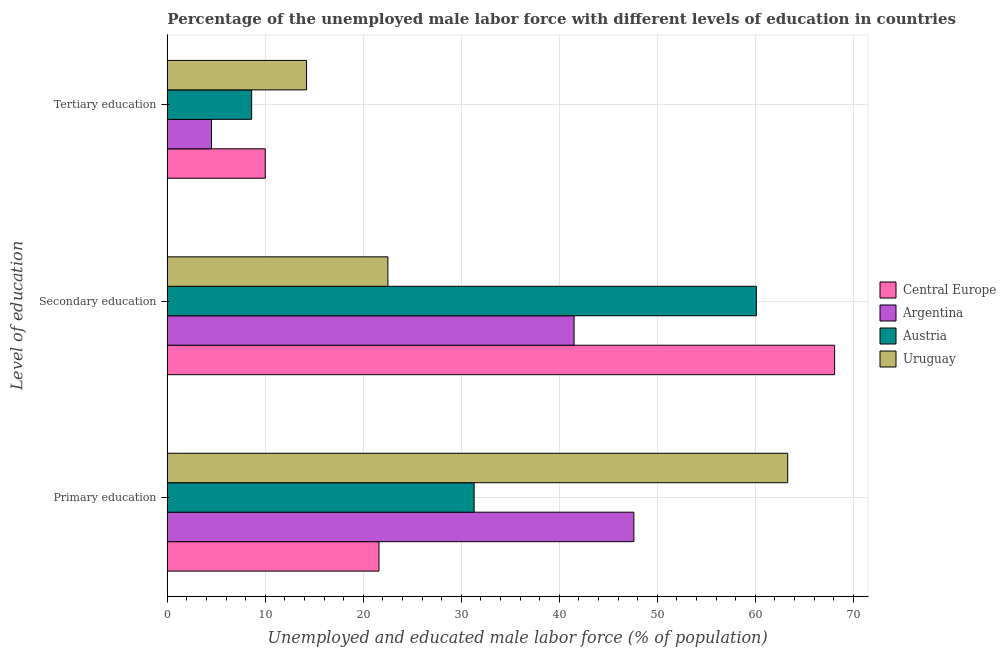How many groups of bars are there?
Your answer should be compact. 3. Are the number of bars on each tick of the Y-axis equal?
Your response must be concise. Yes. How many bars are there on the 1st tick from the top?
Give a very brief answer. 4. Across all countries, what is the maximum percentage of male labor force who received secondary education?
Your response must be concise. 68.09. In which country was the percentage of male labor force who received primary education maximum?
Offer a very short reply. Uruguay. In which country was the percentage of male labor force who received secondary education minimum?
Give a very brief answer. Uruguay. What is the total percentage of male labor force who received tertiary education in the graph?
Provide a short and direct response. 37.28. What is the difference between the percentage of male labor force who received secondary education in Austria and that in Central Europe?
Your response must be concise. -7.99. What is the difference between the percentage of male labor force who received primary education in Uruguay and the percentage of male labor force who received secondary education in Central Europe?
Give a very brief answer. -4.79. What is the average percentage of male labor force who received secondary education per country?
Offer a terse response. 48.05. What is the difference between the percentage of male labor force who received tertiary education and percentage of male labor force who received primary education in Uruguay?
Offer a terse response. -49.1. What is the ratio of the percentage of male labor force who received primary education in Argentina to that in Austria?
Ensure brevity in your answer.  1.52. Is the percentage of male labor force who received secondary education in Uruguay less than that in Argentina?
Your answer should be very brief. Yes. What is the difference between the highest and the second highest percentage of male labor force who received tertiary education?
Your answer should be very brief. 4.22. What is the difference between the highest and the lowest percentage of male labor force who received tertiary education?
Your answer should be compact. 9.7. In how many countries, is the percentage of male labor force who received secondary education greater than the average percentage of male labor force who received secondary education taken over all countries?
Provide a short and direct response. 2. What does the 2nd bar from the top in Primary education represents?
Your answer should be compact. Austria. What does the 3rd bar from the bottom in Secondary education represents?
Give a very brief answer. Austria. How many bars are there?
Offer a very short reply. 12. What is the difference between two consecutive major ticks on the X-axis?
Your answer should be very brief. 10. Are the values on the major ticks of X-axis written in scientific E-notation?
Your answer should be very brief. No. Does the graph contain any zero values?
Give a very brief answer. No. Where does the legend appear in the graph?
Offer a terse response. Center right. How are the legend labels stacked?
Your answer should be very brief. Vertical. What is the title of the graph?
Provide a short and direct response. Percentage of the unemployed male labor force with different levels of education in countries. What is the label or title of the X-axis?
Your answer should be very brief. Unemployed and educated male labor force (% of population). What is the label or title of the Y-axis?
Ensure brevity in your answer.  Level of education. What is the Unemployed and educated male labor force (% of population) in Central Europe in Primary education?
Keep it short and to the point. 21.59. What is the Unemployed and educated male labor force (% of population) of Argentina in Primary education?
Offer a terse response. 47.6. What is the Unemployed and educated male labor force (% of population) of Austria in Primary education?
Ensure brevity in your answer.  31.3. What is the Unemployed and educated male labor force (% of population) of Uruguay in Primary education?
Offer a very short reply. 63.3. What is the Unemployed and educated male labor force (% of population) in Central Europe in Secondary education?
Your response must be concise. 68.09. What is the Unemployed and educated male labor force (% of population) of Argentina in Secondary education?
Offer a terse response. 41.5. What is the Unemployed and educated male labor force (% of population) in Austria in Secondary education?
Keep it short and to the point. 60.1. What is the Unemployed and educated male labor force (% of population) in Central Europe in Tertiary education?
Provide a short and direct response. 9.98. What is the Unemployed and educated male labor force (% of population) in Austria in Tertiary education?
Provide a short and direct response. 8.6. What is the Unemployed and educated male labor force (% of population) in Uruguay in Tertiary education?
Provide a short and direct response. 14.2. Across all Level of education, what is the maximum Unemployed and educated male labor force (% of population) of Central Europe?
Offer a terse response. 68.09. Across all Level of education, what is the maximum Unemployed and educated male labor force (% of population) of Argentina?
Ensure brevity in your answer.  47.6. Across all Level of education, what is the maximum Unemployed and educated male labor force (% of population) in Austria?
Offer a terse response. 60.1. Across all Level of education, what is the maximum Unemployed and educated male labor force (% of population) in Uruguay?
Your answer should be compact. 63.3. Across all Level of education, what is the minimum Unemployed and educated male labor force (% of population) of Central Europe?
Keep it short and to the point. 9.98. Across all Level of education, what is the minimum Unemployed and educated male labor force (% of population) in Austria?
Keep it short and to the point. 8.6. Across all Level of education, what is the minimum Unemployed and educated male labor force (% of population) in Uruguay?
Provide a succinct answer. 14.2. What is the total Unemployed and educated male labor force (% of population) in Central Europe in the graph?
Make the answer very short. 99.66. What is the total Unemployed and educated male labor force (% of population) in Argentina in the graph?
Make the answer very short. 93.6. What is the total Unemployed and educated male labor force (% of population) of Austria in the graph?
Your response must be concise. 100. What is the difference between the Unemployed and educated male labor force (% of population) in Central Europe in Primary education and that in Secondary education?
Give a very brief answer. -46.49. What is the difference between the Unemployed and educated male labor force (% of population) of Austria in Primary education and that in Secondary education?
Your answer should be compact. -28.8. What is the difference between the Unemployed and educated male labor force (% of population) in Uruguay in Primary education and that in Secondary education?
Give a very brief answer. 40.8. What is the difference between the Unemployed and educated male labor force (% of population) of Central Europe in Primary education and that in Tertiary education?
Make the answer very short. 11.61. What is the difference between the Unemployed and educated male labor force (% of population) of Argentina in Primary education and that in Tertiary education?
Make the answer very short. 43.1. What is the difference between the Unemployed and educated male labor force (% of population) in Austria in Primary education and that in Tertiary education?
Offer a terse response. 22.7. What is the difference between the Unemployed and educated male labor force (% of population) in Uruguay in Primary education and that in Tertiary education?
Your answer should be compact. 49.1. What is the difference between the Unemployed and educated male labor force (% of population) of Central Europe in Secondary education and that in Tertiary education?
Offer a terse response. 58.1. What is the difference between the Unemployed and educated male labor force (% of population) of Austria in Secondary education and that in Tertiary education?
Ensure brevity in your answer.  51.5. What is the difference between the Unemployed and educated male labor force (% of population) in Uruguay in Secondary education and that in Tertiary education?
Offer a very short reply. 8.3. What is the difference between the Unemployed and educated male labor force (% of population) in Central Europe in Primary education and the Unemployed and educated male labor force (% of population) in Argentina in Secondary education?
Ensure brevity in your answer.  -19.91. What is the difference between the Unemployed and educated male labor force (% of population) of Central Europe in Primary education and the Unemployed and educated male labor force (% of population) of Austria in Secondary education?
Offer a terse response. -38.51. What is the difference between the Unemployed and educated male labor force (% of population) in Central Europe in Primary education and the Unemployed and educated male labor force (% of population) in Uruguay in Secondary education?
Your answer should be compact. -0.91. What is the difference between the Unemployed and educated male labor force (% of population) of Argentina in Primary education and the Unemployed and educated male labor force (% of population) of Uruguay in Secondary education?
Provide a succinct answer. 25.1. What is the difference between the Unemployed and educated male labor force (% of population) in Austria in Primary education and the Unemployed and educated male labor force (% of population) in Uruguay in Secondary education?
Make the answer very short. 8.8. What is the difference between the Unemployed and educated male labor force (% of population) of Central Europe in Primary education and the Unemployed and educated male labor force (% of population) of Argentina in Tertiary education?
Ensure brevity in your answer.  17.09. What is the difference between the Unemployed and educated male labor force (% of population) in Central Europe in Primary education and the Unemployed and educated male labor force (% of population) in Austria in Tertiary education?
Make the answer very short. 12.99. What is the difference between the Unemployed and educated male labor force (% of population) of Central Europe in Primary education and the Unemployed and educated male labor force (% of population) of Uruguay in Tertiary education?
Provide a succinct answer. 7.39. What is the difference between the Unemployed and educated male labor force (% of population) in Argentina in Primary education and the Unemployed and educated male labor force (% of population) in Uruguay in Tertiary education?
Your answer should be very brief. 33.4. What is the difference between the Unemployed and educated male labor force (% of population) in Central Europe in Secondary education and the Unemployed and educated male labor force (% of population) in Argentina in Tertiary education?
Your answer should be very brief. 63.59. What is the difference between the Unemployed and educated male labor force (% of population) of Central Europe in Secondary education and the Unemployed and educated male labor force (% of population) of Austria in Tertiary education?
Ensure brevity in your answer.  59.49. What is the difference between the Unemployed and educated male labor force (% of population) of Central Europe in Secondary education and the Unemployed and educated male labor force (% of population) of Uruguay in Tertiary education?
Offer a terse response. 53.89. What is the difference between the Unemployed and educated male labor force (% of population) of Argentina in Secondary education and the Unemployed and educated male labor force (% of population) of Austria in Tertiary education?
Give a very brief answer. 32.9. What is the difference between the Unemployed and educated male labor force (% of population) in Argentina in Secondary education and the Unemployed and educated male labor force (% of population) in Uruguay in Tertiary education?
Keep it short and to the point. 27.3. What is the difference between the Unemployed and educated male labor force (% of population) in Austria in Secondary education and the Unemployed and educated male labor force (% of population) in Uruguay in Tertiary education?
Provide a succinct answer. 45.9. What is the average Unemployed and educated male labor force (% of population) in Central Europe per Level of education?
Your answer should be very brief. 33.22. What is the average Unemployed and educated male labor force (% of population) in Argentina per Level of education?
Your answer should be very brief. 31.2. What is the average Unemployed and educated male labor force (% of population) in Austria per Level of education?
Your response must be concise. 33.33. What is the average Unemployed and educated male labor force (% of population) in Uruguay per Level of education?
Offer a very short reply. 33.33. What is the difference between the Unemployed and educated male labor force (% of population) of Central Europe and Unemployed and educated male labor force (% of population) of Argentina in Primary education?
Your response must be concise. -26.01. What is the difference between the Unemployed and educated male labor force (% of population) of Central Europe and Unemployed and educated male labor force (% of population) of Austria in Primary education?
Your answer should be very brief. -9.71. What is the difference between the Unemployed and educated male labor force (% of population) in Central Europe and Unemployed and educated male labor force (% of population) in Uruguay in Primary education?
Your response must be concise. -41.71. What is the difference between the Unemployed and educated male labor force (% of population) in Argentina and Unemployed and educated male labor force (% of population) in Uruguay in Primary education?
Provide a succinct answer. -15.7. What is the difference between the Unemployed and educated male labor force (% of population) of Austria and Unemployed and educated male labor force (% of population) of Uruguay in Primary education?
Offer a very short reply. -32. What is the difference between the Unemployed and educated male labor force (% of population) of Central Europe and Unemployed and educated male labor force (% of population) of Argentina in Secondary education?
Give a very brief answer. 26.59. What is the difference between the Unemployed and educated male labor force (% of population) in Central Europe and Unemployed and educated male labor force (% of population) in Austria in Secondary education?
Ensure brevity in your answer.  7.99. What is the difference between the Unemployed and educated male labor force (% of population) of Central Europe and Unemployed and educated male labor force (% of population) of Uruguay in Secondary education?
Provide a succinct answer. 45.59. What is the difference between the Unemployed and educated male labor force (% of population) of Argentina and Unemployed and educated male labor force (% of population) of Austria in Secondary education?
Your answer should be compact. -18.6. What is the difference between the Unemployed and educated male labor force (% of population) in Austria and Unemployed and educated male labor force (% of population) in Uruguay in Secondary education?
Provide a short and direct response. 37.6. What is the difference between the Unemployed and educated male labor force (% of population) of Central Europe and Unemployed and educated male labor force (% of population) of Argentina in Tertiary education?
Ensure brevity in your answer.  5.48. What is the difference between the Unemployed and educated male labor force (% of population) in Central Europe and Unemployed and educated male labor force (% of population) in Austria in Tertiary education?
Your response must be concise. 1.38. What is the difference between the Unemployed and educated male labor force (% of population) of Central Europe and Unemployed and educated male labor force (% of population) of Uruguay in Tertiary education?
Your response must be concise. -4.22. What is the difference between the Unemployed and educated male labor force (% of population) in Argentina and Unemployed and educated male labor force (% of population) in Uruguay in Tertiary education?
Provide a succinct answer. -9.7. What is the ratio of the Unemployed and educated male labor force (% of population) of Central Europe in Primary education to that in Secondary education?
Offer a terse response. 0.32. What is the ratio of the Unemployed and educated male labor force (% of population) in Argentina in Primary education to that in Secondary education?
Keep it short and to the point. 1.15. What is the ratio of the Unemployed and educated male labor force (% of population) in Austria in Primary education to that in Secondary education?
Your answer should be compact. 0.52. What is the ratio of the Unemployed and educated male labor force (% of population) of Uruguay in Primary education to that in Secondary education?
Offer a terse response. 2.81. What is the ratio of the Unemployed and educated male labor force (% of population) of Central Europe in Primary education to that in Tertiary education?
Your answer should be very brief. 2.16. What is the ratio of the Unemployed and educated male labor force (% of population) in Argentina in Primary education to that in Tertiary education?
Give a very brief answer. 10.58. What is the ratio of the Unemployed and educated male labor force (% of population) of Austria in Primary education to that in Tertiary education?
Keep it short and to the point. 3.64. What is the ratio of the Unemployed and educated male labor force (% of population) of Uruguay in Primary education to that in Tertiary education?
Your answer should be very brief. 4.46. What is the ratio of the Unemployed and educated male labor force (% of population) of Central Europe in Secondary education to that in Tertiary education?
Keep it short and to the point. 6.82. What is the ratio of the Unemployed and educated male labor force (% of population) in Argentina in Secondary education to that in Tertiary education?
Ensure brevity in your answer.  9.22. What is the ratio of the Unemployed and educated male labor force (% of population) of Austria in Secondary education to that in Tertiary education?
Offer a terse response. 6.99. What is the ratio of the Unemployed and educated male labor force (% of population) of Uruguay in Secondary education to that in Tertiary education?
Offer a terse response. 1.58. What is the difference between the highest and the second highest Unemployed and educated male labor force (% of population) of Central Europe?
Your answer should be compact. 46.49. What is the difference between the highest and the second highest Unemployed and educated male labor force (% of population) of Austria?
Offer a terse response. 28.8. What is the difference between the highest and the second highest Unemployed and educated male labor force (% of population) in Uruguay?
Make the answer very short. 40.8. What is the difference between the highest and the lowest Unemployed and educated male labor force (% of population) in Central Europe?
Your answer should be very brief. 58.1. What is the difference between the highest and the lowest Unemployed and educated male labor force (% of population) in Argentina?
Provide a short and direct response. 43.1. What is the difference between the highest and the lowest Unemployed and educated male labor force (% of population) in Austria?
Keep it short and to the point. 51.5. What is the difference between the highest and the lowest Unemployed and educated male labor force (% of population) of Uruguay?
Offer a terse response. 49.1. 